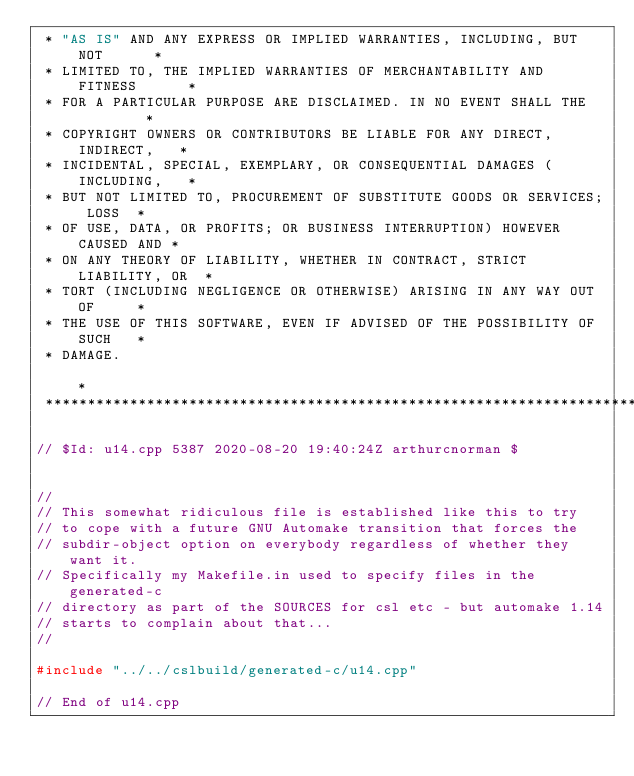Convert code to text. <code><loc_0><loc_0><loc_500><loc_500><_C++_> * "AS IS" AND ANY EXPRESS OR IMPLIED WARRANTIES, INCLUDING, BUT NOT      *
 * LIMITED TO, THE IMPLIED WARRANTIES OF MERCHANTABILITY AND FITNESS      *
 * FOR A PARTICULAR PURPOSE ARE DISCLAIMED. IN NO EVENT SHALL THE         *
 * COPYRIGHT OWNERS OR CONTRIBUTORS BE LIABLE FOR ANY DIRECT, INDIRECT,   *
 * INCIDENTAL, SPECIAL, EXEMPLARY, OR CONSEQUENTIAL DAMAGES (INCLUDING,   *
 * BUT NOT LIMITED TO, PROCUREMENT OF SUBSTITUTE GOODS OR SERVICES; LOSS  *
 * OF USE, DATA, OR PROFITS; OR BUSINESS INTERRUPTION) HOWEVER CAUSED AND *
 * ON ANY THEORY OF LIABILITY, WHETHER IN CONTRACT, STRICT LIABILITY, OR  *
 * TORT (INCLUDING NEGLIGENCE OR OTHERWISE) ARISING IN ANY WAY OUT OF     *
 * THE USE OF THIS SOFTWARE, EVEN IF ADVISED OF THE POSSIBILITY OF SUCH   *
 * DAMAGE.                                                                *
 *************************************************************************/

// $Id: u14.cpp 5387 2020-08-20 19:40:24Z arthurcnorman $


//
// This somewhat ridiculous file is established like this to try
// to cope with a future GNU Automake transition that forces the
// subdir-object option on everybody regardless of whether they want it.
// Specifically my Makefile.in used to specify files in the generated-c
// directory as part of the SOURCES for csl etc - but automake 1.14
// starts to complain about that...
//

#include "../../cslbuild/generated-c/u14.cpp"

// End of u14.cpp
</code> 